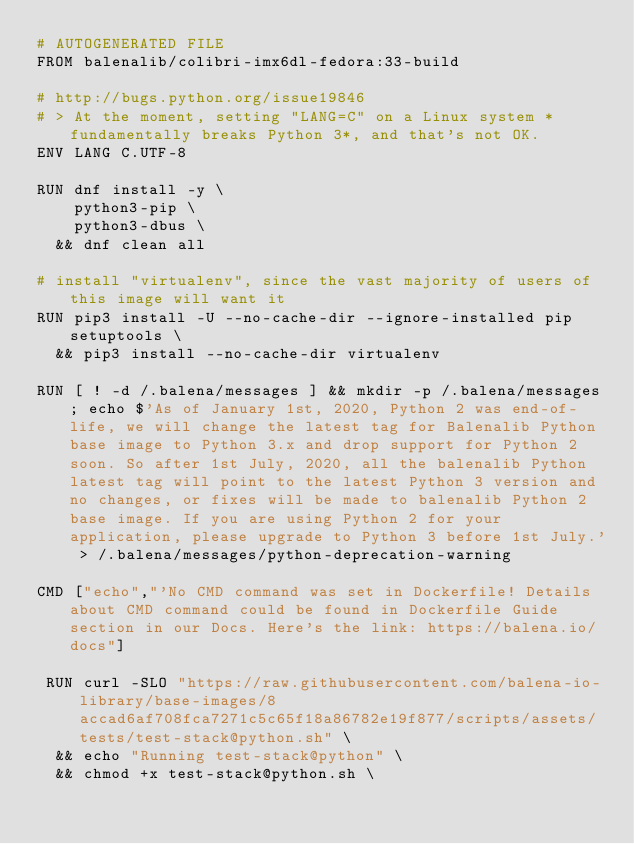Convert code to text. <code><loc_0><loc_0><loc_500><loc_500><_Dockerfile_># AUTOGENERATED FILE
FROM balenalib/colibri-imx6dl-fedora:33-build

# http://bugs.python.org/issue19846
# > At the moment, setting "LANG=C" on a Linux system *fundamentally breaks Python 3*, and that's not OK.
ENV LANG C.UTF-8

RUN dnf install -y \
		python3-pip \
		python3-dbus \
	&& dnf clean all

# install "virtualenv", since the vast majority of users of this image will want it
RUN pip3 install -U --no-cache-dir --ignore-installed pip setuptools \
	&& pip3 install --no-cache-dir virtualenv

RUN [ ! -d /.balena/messages ] && mkdir -p /.balena/messages; echo $'As of January 1st, 2020, Python 2 was end-of-life, we will change the latest tag for Balenalib Python base image to Python 3.x and drop support for Python 2 soon. So after 1st July, 2020, all the balenalib Python latest tag will point to the latest Python 3 version and no changes, or fixes will be made to balenalib Python 2 base image. If you are using Python 2 for your application, please upgrade to Python 3 before 1st July.' > /.balena/messages/python-deprecation-warning

CMD ["echo","'No CMD command was set in Dockerfile! Details about CMD command could be found in Dockerfile Guide section in our Docs. Here's the link: https://balena.io/docs"]

 RUN curl -SLO "https://raw.githubusercontent.com/balena-io-library/base-images/8accad6af708fca7271c5c65f18a86782e19f877/scripts/assets/tests/test-stack@python.sh" \
  && echo "Running test-stack@python" \
  && chmod +x test-stack@python.sh \</code> 